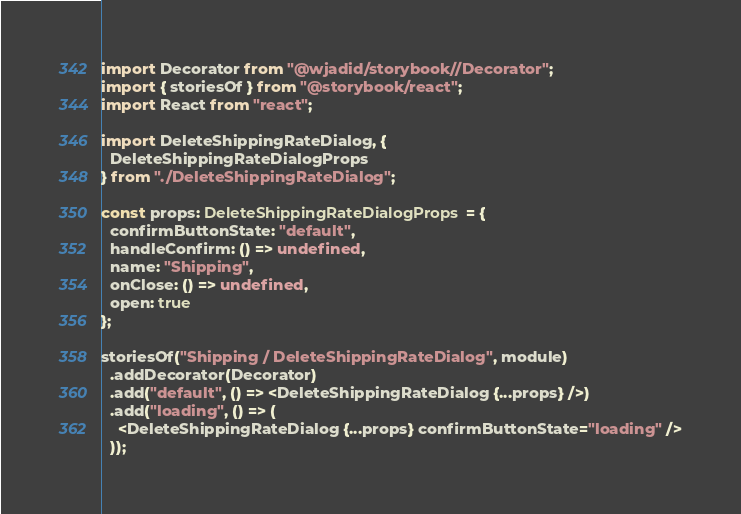Convert code to text. <code><loc_0><loc_0><loc_500><loc_500><_TypeScript_>import Decorator from "@wjadid/storybook//Decorator";
import { storiesOf } from "@storybook/react";
import React from "react";

import DeleteShippingRateDialog, {
  DeleteShippingRateDialogProps
} from "./DeleteShippingRateDialog";

const props: DeleteShippingRateDialogProps = {
  confirmButtonState: "default",
  handleConfirm: () => undefined,
  name: "Shipping",
  onClose: () => undefined,
  open: true
};

storiesOf("Shipping / DeleteShippingRateDialog", module)
  .addDecorator(Decorator)
  .add("default", () => <DeleteShippingRateDialog {...props} />)
  .add("loading", () => (
    <DeleteShippingRateDialog {...props} confirmButtonState="loading" />
  ));
</code> 